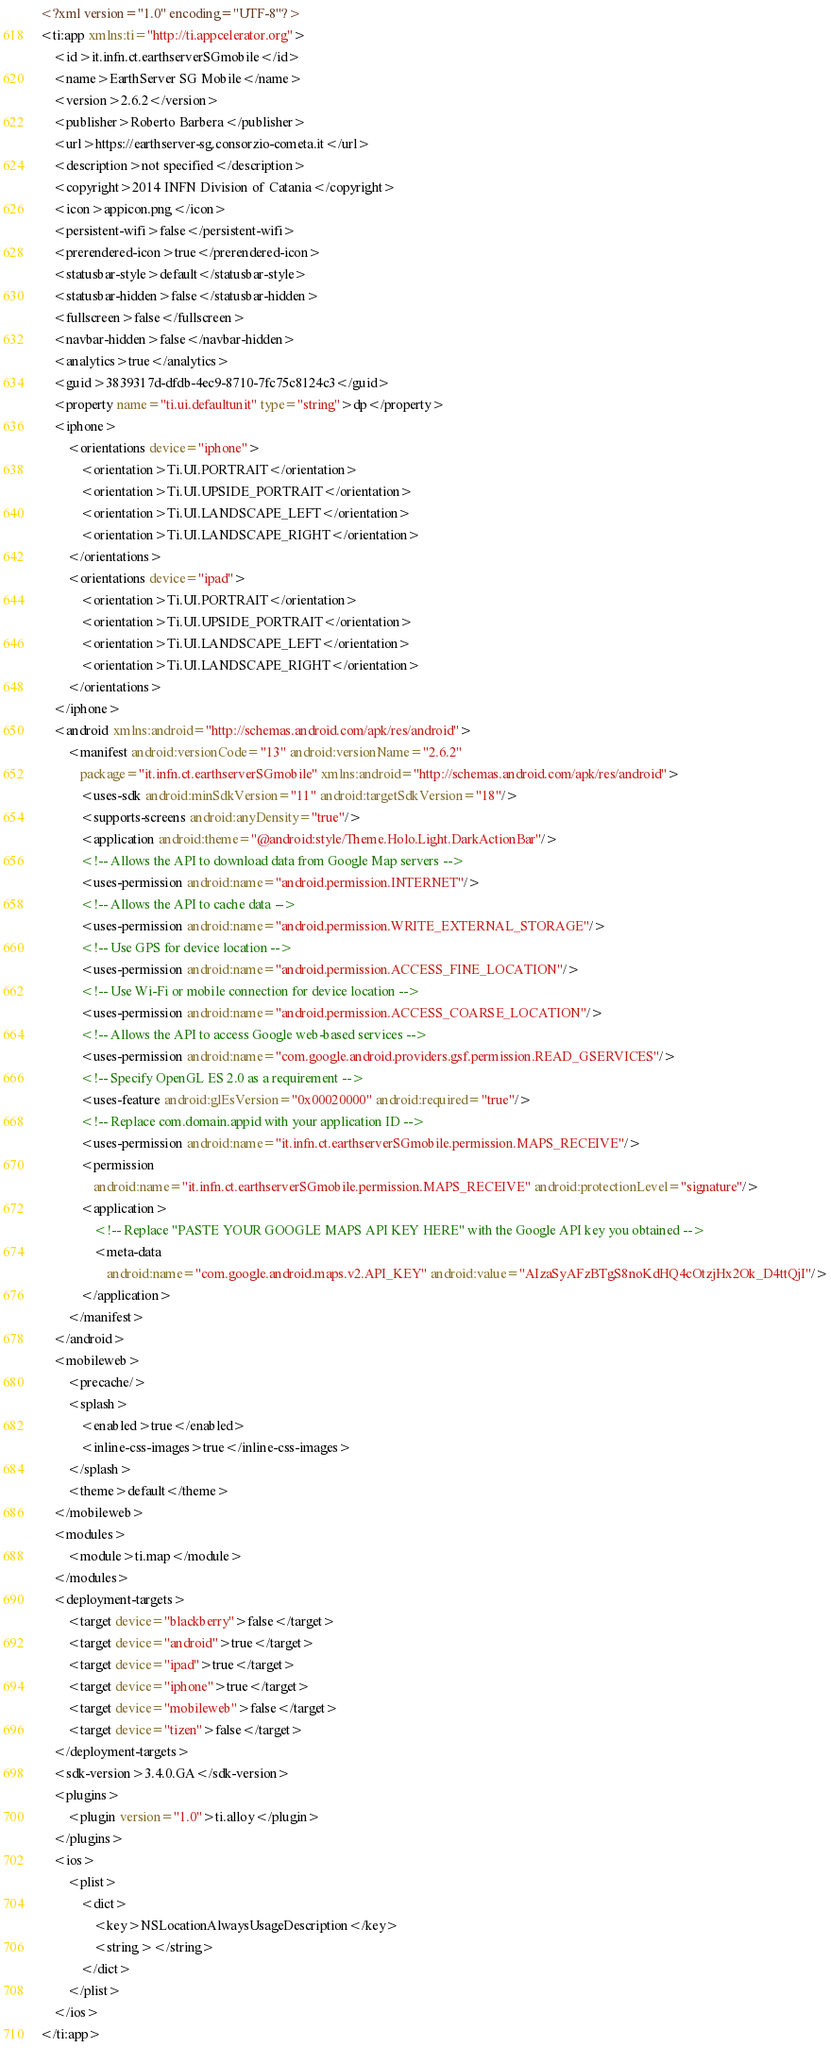<code> <loc_0><loc_0><loc_500><loc_500><_XML_><?xml version="1.0" encoding="UTF-8"?>
<ti:app xmlns:ti="http://ti.appcelerator.org">
    <id>it.infn.ct.earthserverSGmobile</id>
    <name>EarthServer SG Mobile</name>
    <version>2.6.2</version>
    <publisher>Roberto Barbera</publisher>
    <url>https://earthserver-sg.consorzio-cometa.it</url>
    <description>not specified</description>
    <copyright>2014 INFN Division of Catania</copyright>
    <icon>appicon.png</icon>
    <persistent-wifi>false</persistent-wifi>
    <prerendered-icon>true</prerendered-icon>
    <statusbar-style>default</statusbar-style>
    <statusbar-hidden>false</statusbar-hidden>
    <fullscreen>false</fullscreen>
    <navbar-hidden>false</navbar-hidden>
    <analytics>true</analytics>
    <guid>3839317d-dfdb-4ec9-8710-7fc75c8124c3</guid>
    <property name="ti.ui.defaultunit" type="string">dp</property>
    <iphone>
        <orientations device="iphone">
            <orientation>Ti.UI.PORTRAIT</orientation>
            <orientation>Ti.UI.UPSIDE_PORTRAIT</orientation>
            <orientation>Ti.UI.LANDSCAPE_LEFT</orientation>
            <orientation>Ti.UI.LANDSCAPE_RIGHT</orientation>
        </orientations>
        <orientations device="ipad">
            <orientation>Ti.UI.PORTRAIT</orientation>
            <orientation>Ti.UI.UPSIDE_PORTRAIT</orientation>
            <orientation>Ti.UI.LANDSCAPE_LEFT</orientation>
            <orientation>Ti.UI.LANDSCAPE_RIGHT</orientation>
        </orientations>
    </iphone>
    <android xmlns:android="http://schemas.android.com/apk/res/android">
        <manifest android:versionCode="13" android:versionName="2.6.2"
            package="it.infn.ct.earthserverSGmobile" xmlns:android="http://schemas.android.com/apk/res/android">
            <uses-sdk android:minSdkVersion="11" android:targetSdkVersion="18"/>
            <supports-screens android:anyDensity="true"/>
            <application android:theme="@android:style/Theme.Holo.Light.DarkActionBar"/>
            <!-- Allows the API to download data from Google Map servers -->
            <uses-permission android:name="android.permission.INTERNET"/>
            <!-- Allows the API to cache data -->
            <uses-permission android:name="android.permission.WRITE_EXTERNAL_STORAGE"/>
            <!-- Use GPS for device location -->
            <uses-permission android:name="android.permission.ACCESS_FINE_LOCATION"/>
            <!-- Use Wi-Fi or mobile connection for device location -->
            <uses-permission android:name="android.permission.ACCESS_COARSE_LOCATION"/>
            <!-- Allows the API to access Google web-based services -->
            <uses-permission android:name="com.google.android.providers.gsf.permission.READ_GSERVICES"/>
            <!-- Specify OpenGL ES 2.0 as a requirement -->
            <uses-feature android:glEsVersion="0x00020000" android:required="true"/>
            <!-- Replace com.domain.appid with your application ID -->
            <uses-permission android:name="it.infn.ct.earthserverSGmobile.permission.MAPS_RECEIVE"/>
            <permission
                android:name="it.infn.ct.earthserverSGmobile.permission.MAPS_RECEIVE" android:protectionLevel="signature"/>
            <application>
                <!-- Replace "PASTE YOUR GOOGLE MAPS API KEY HERE" with the Google API key you obtained -->
                <meta-data
                    android:name="com.google.android.maps.v2.API_KEY" android:value="AIzaSyAFzBTgS8noKdHQ4cOtzjHx2Ok_D4ttQjI"/>
            </application>
        </manifest>
    </android>
    <mobileweb>
        <precache/>
        <splash>
            <enabled>true</enabled>
            <inline-css-images>true</inline-css-images>
        </splash>
        <theme>default</theme>
    </mobileweb>
    <modules>
        <module>ti.map</module>
    </modules>
    <deployment-targets>
        <target device="blackberry">false</target>
        <target device="android">true</target>
        <target device="ipad">true</target>
        <target device="iphone">true</target>
        <target device="mobileweb">false</target>
        <target device="tizen">false</target>
    </deployment-targets>
    <sdk-version>3.4.0.GA</sdk-version>
    <plugins>
        <plugin version="1.0">ti.alloy</plugin>
    </plugins>
    <ios>
        <plist>
            <dict>
                <key>NSLocationAlwaysUsageDescription</key>
                <string></string>
            </dict>
        </plist>
    </ios>
</ti:app>
</code> 